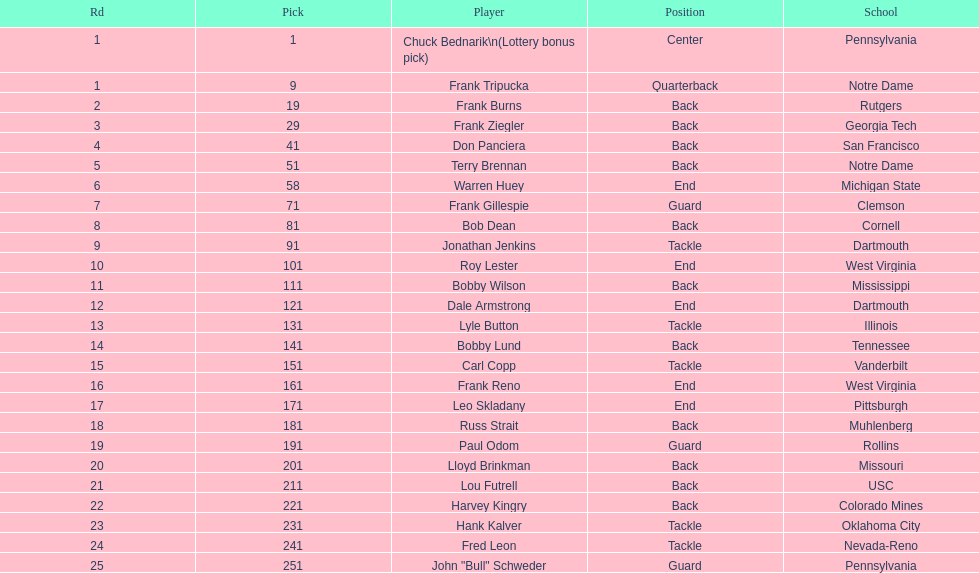How many players were from notre dame? 2. 